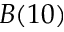Convert formula to latex. <formula><loc_0><loc_0><loc_500><loc_500>B ( 1 0 )</formula> 